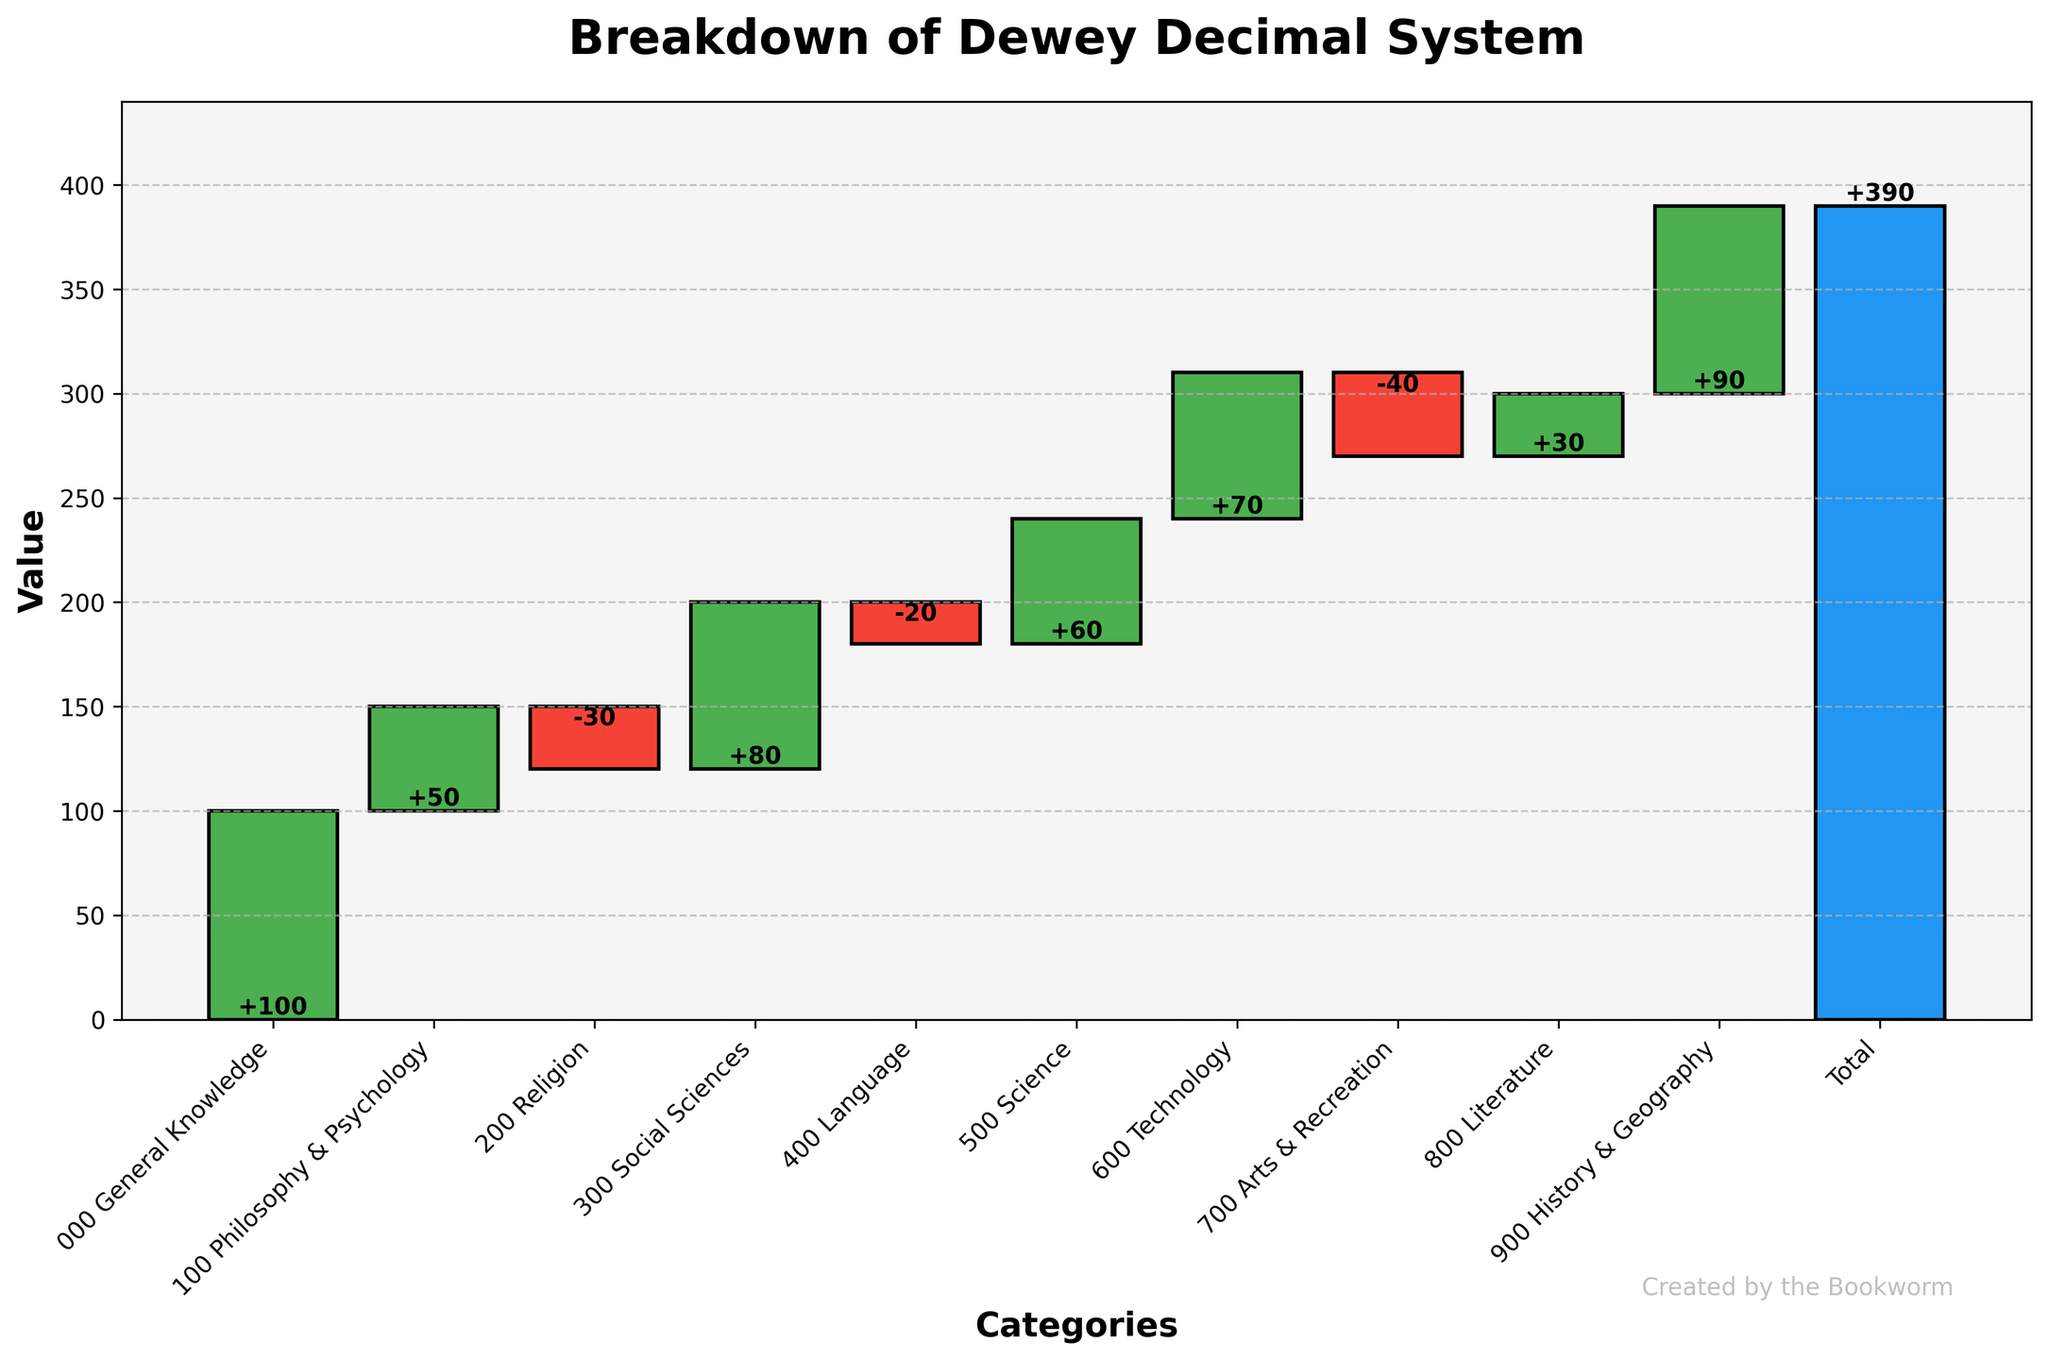what is the title of the plot? The title is prominently displayed at the top of the figure. It provides a summary of what the figure represents. In this case, it clearly states "Breakdown of Dewey Decimal System."
Answer: Breakdown of Dewey Decimal System what are the axis labels, and what do they indicate? The x-axis label is "Categories," indicating that the horizontal direction lists different major categories of the Dewey Decimal System. The y-axis label is "Value," which signifies the numerical values representing the composition breakdown of these categories.
Answer: Categories (x-axis) and Value (y-axis) which category has the highest value, and what is it? By visually scanning the bars, the tallest positive bar represents the category with the highest value. In this plot, "History & Geography" is the highest, with a value of +90.
Answer: History & Geography (+90) compare the values of Science and Technology. Which category has a higher value and by how much? The bar heights reveal that "Technology" has a higher value than "Science." Subtracting the value of Science (+60) from Technology (+70) gives the difference. 70 - 60 = 10.
Answer: Technology by 10 what is the total value represented in the plot? The total bar at the end of the x-axis denotes the overall sum of all category values. According to the label, this value is 390.
Answer: 390 find the sum of the values of categories with negative values. What is it? Identify categories with negative values: Religion (-30), Language (-20), Arts & Recreation (-40). Sum these values: -30 + -20 + -40 = -90.
Answer: -90 how much does the "General Knowledge" category contribute to the total value? The value of "General Knowledge" is 100. This is its direct contribution to the total.
Answer: 100 how many categories have positive values, and list them. Positive values indicate bars above the zero-line. Categories: General Knowledge, Philosophy & Psychology, Social Sciences, Science, Technology, Literature, History & Geography (7 categories).
Answer: 7 categories: General Knowledge, Philosophy & Psychology, Social Sciences, Science, Technology, Literature, History & Geography which two categories have the closest values, and what are their values? By visually comparing the bar heights, "Science" (+60) and "Literature" (+30) are closer to other values, differing by a span.
Answer: Science (60) and Technology (70) what is the difference between the highest and lowest values among the categories? Identify highest: History & Geography (+90), and lowest: Arts & Recreation (-40). Calculate the difference: 90 - (-40) = 130.
Answer: 130 